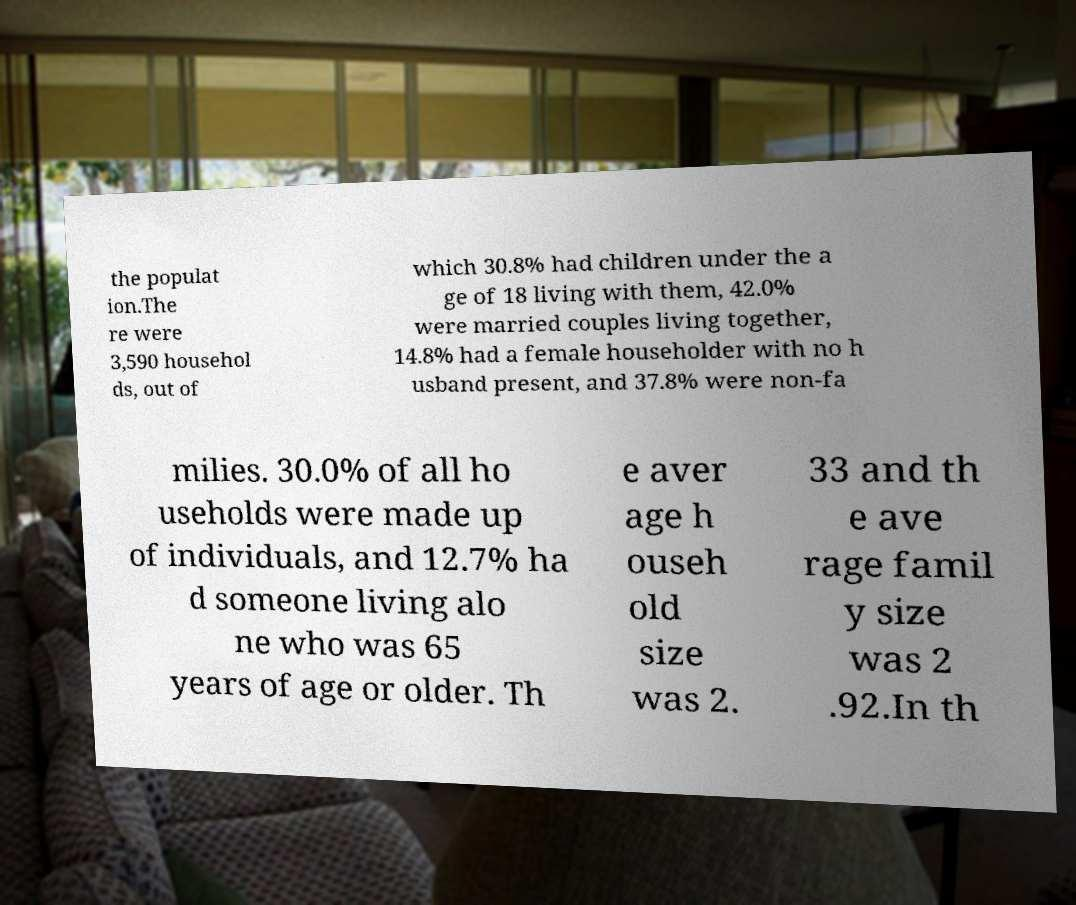Could you assist in decoding the text presented in this image and type it out clearly? the populat ion.The re were 3,590 househol ds, out of which 30.8% had children under the a ge of 18 living with them, 42.0% were married couples living together, 14.8% had a female householder with no h usband present, and 37.8% were non-fa milies. 30.0% of all ho useholds were made up of individuals, and 12.7% ha d someone living alo ne who was 65 years of age or older. Th e aver age h ouseh old size was 2. 33 and th e ave rage famil y size was 2 .92.In th 